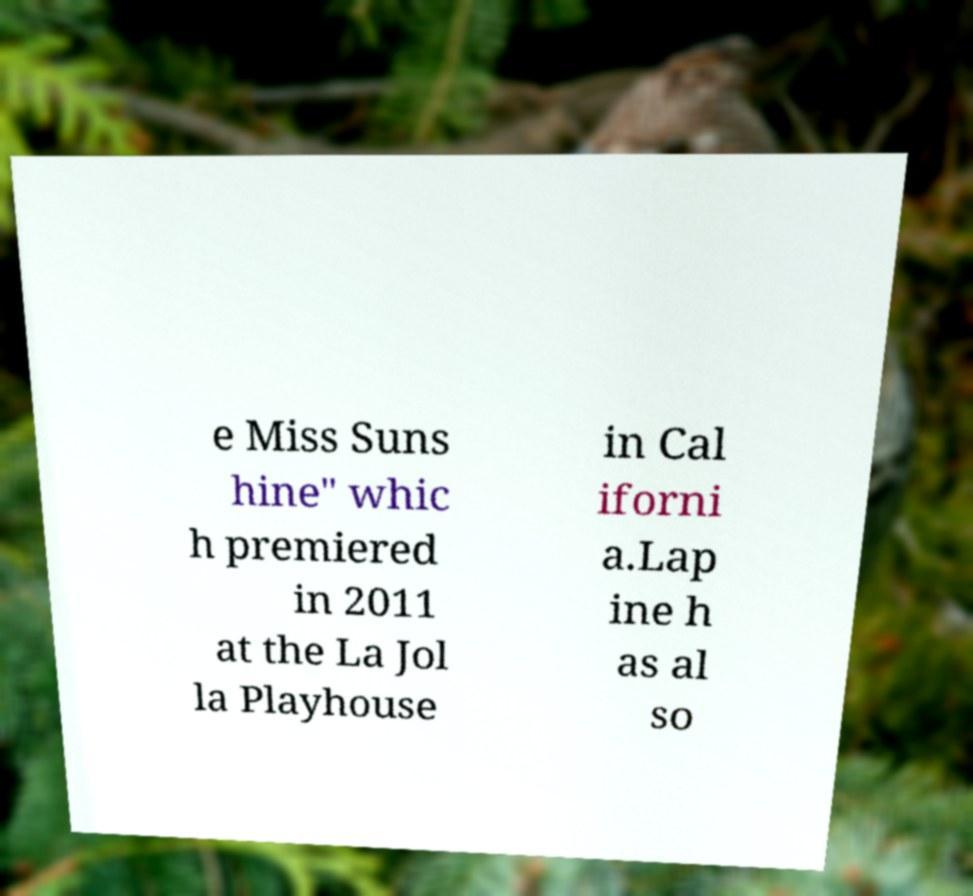Please identify and transcribe the text found in this image. e Miss Suns hine" whic h premiered in 2011 at the La Jol la Playhouse in Cal iforni a.Lap ine h as al so 